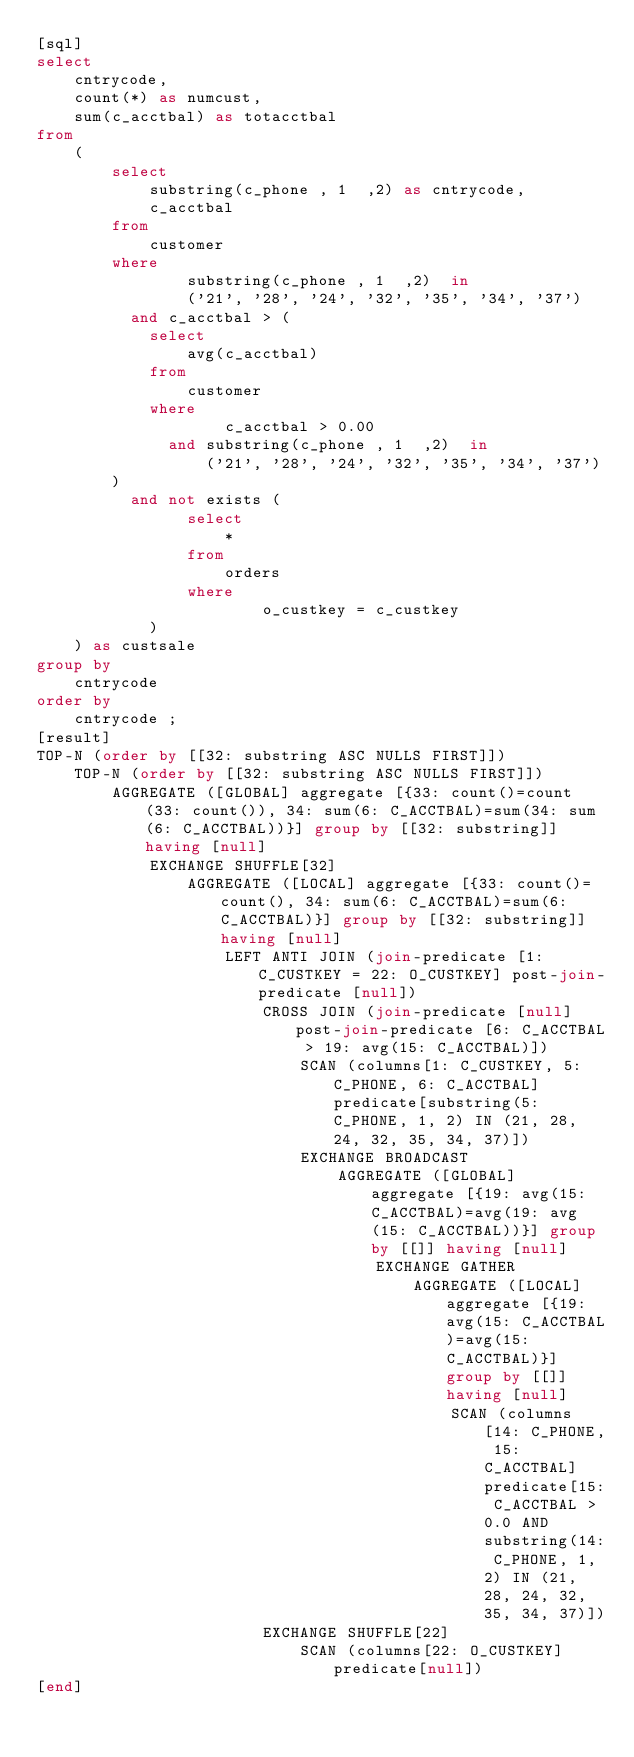Convert code to text. <code><loc_0><loc_0><loc_500><loc_500><_SQL_>[sql]
select
    cntrycode,
    count(*) as numcust,
    sum(c_acctbal) as totacctbal
from
    (
        select
            substring(c_phone , 1  ,2) as cntrycode,
            c_acctbal
        from
            customer
        where
                substring(c_phone , 1  ,2)  in
                ('21', '28', '24', '32', '35', '34', '37')
          and c_acctbal > (
            select
                avg(c_acctbal)
            from
                customer
            where
                    c_acctbal > 0.00
              and substring(c_phone , 1  ,2)  in
                  ('21', '28', '24', '32', '35', '34', '37')
        )
          and not exists (
                select
                    *
                from
                    orders
                where
                        o_custkey = c_custkey
            )
    ) as custsale
group by
    cntrycode
order by
    cntrycode ;
[result]
TOP-N (order by [[32: substring ASC NULLS FIRST]])
    TOP-N (order by [[32: substring ASC NULLS FIRST]])
        AGGREGATE ([GLOBAL] aggregate [{33: count()=count(33: count()), 34: sum(6: C_ACCTBAL)=sum(34: sum(6: C_ACCTBAL))}] group by [[32: substring]] having [null]
            EXCHANGE SHUFFLE[32]
                AGGREGATE ([LOCAL] aggregate [{33: count()=count(), 34: sum(6: C_ACCTBAL)=sum(6: C_ACCTBAL)}] group by [[32: substring]] having [null]
                    LEFT ANTI JOIN (join-predicate [1: C_CUSTKEY = 22: O_CUSTKEY] post-join-predicate [null])
                        CROSS JOIN (join-predicate [null] post-join-predicate [6: C_ACCTBAL > 19: avg(15: C_ACCTBAL)])
                            SCAN (columns[1: C_CUSTKEY, 5: C_PHONE, 6: C_ACCTBAL] predicate[substring(5: C_PHONE, 1, 2) IN (21, 28, 24, 32, 35, 34, 37)])
                            EXCHANGE BROADCAST
                                AGGREGATE ([GLOBAL] aggregate [{19: avg(15: C_ACCTBAL)=avg(19: avg(15: C_ACCTBAL))}] group by [[]] having [null]
                                    EXCHANGE GATHER
                                        AGGREGATE ([LOCAL] aggregate [{19: avg(15: C_ACCTBAL)=avg(15: C_ACCTBAL)}] group by [[]] having [null]
                                            SCAN (columns[14: C_PHONE, 15: C_ACCTBAL] predicate[15: C_ACCTBAL > 0.0 AND substring(14: C_PHONE, 1, 2) IN (21, 28, 24, 32, 35, 34, 37)])
                        EXCHANGE SHUFFLE[22]
                            SCAN (columns[22: O_CUSTKEY] predicate[null])
[end]

</code> 